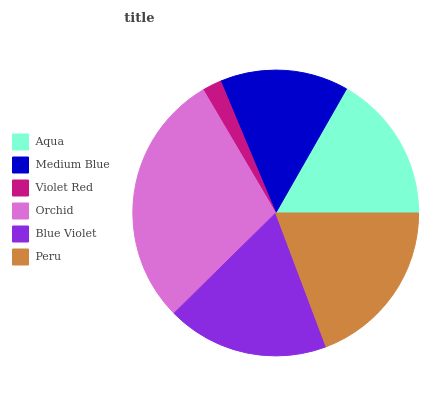Is Violet Red the minimum?
Answer yes or no. Yes. Is Orchid the maximum?
Answer yes or no. Yes. Is Medium Blue the minimum?
Answer yes or no. No. Is Medium Blue the maximum?
Answer yes or no. No. Is Aqua greater than Medium Blue?
Answer yes or no. Yes. Is Medium Blue less than Aqua?
Answer yes or no. Yes. Is Medium Blue greater than Aqua?
Answer yes or no. No. Is Aqua less than Medium Blue?
Answer yes or no. No. Is Blue Violet the high median?
Answer yes or no. Yes. Is Aqua the low median?
Answer yes or no. Yes. Is Orchid the high median?
Answer yes or no. No. Is Medium Blue the low median?
Answer yes or no. No. 